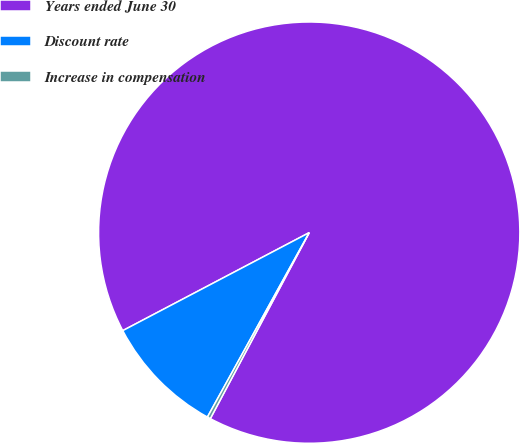Convert chart to OTSL. <chart><loc_0><loc_0><loc_500><loc_500><pie_chart><fcel>Years ended June 30<fcel>Discount rate<fcel>Increase in compensation<nl><fcel>90.48%<fcel>9.27%<fcel>0.25%<nl></chart> 